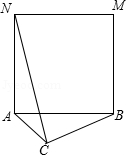If square ABMN were to increase in size, how would that affect the maximum length of CN? If square ABMN were to expand, maintaining its square shape, the side lengths, specifically AB and AN which equal each other, would increase. This growth affects triangle ACB since AB is a side of this triangle. As AB lengthens, AC remains constant, implying that the triangle would become more obtuse at angle ACB. This shifts point C further out along CN when we perform the 90° rotation around point A. The conclusion? The maximal length of CN would correspondingly increase, as it extends with the size of the expanded square. 